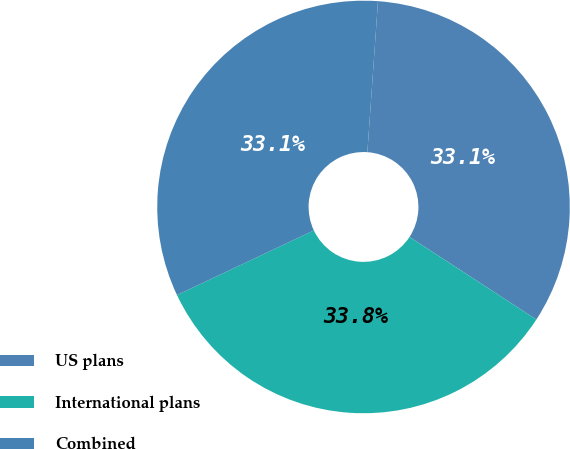Convert chart. <chart><loc_0><loc_0><loc_500><loc_500><pie_chart><fcel>US plans<fcel>International plans<fcel>Combined<nl><fcel>33.07%<fcel>33.79%<fcel>33.14%<nl></chart> 